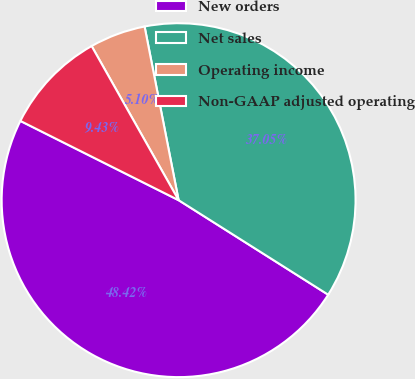<chart> <loc_0><loc_0><loc_500><loc_500><pie_chart><fcel>New orders<fcel>Net sales<fcel>Operating income<fcel>Non-GAAP adjusted operating<nl><fcel>48.42%<fcel>37.05%<fcel>5.1%<fcel>9.43%<nl></chart> 